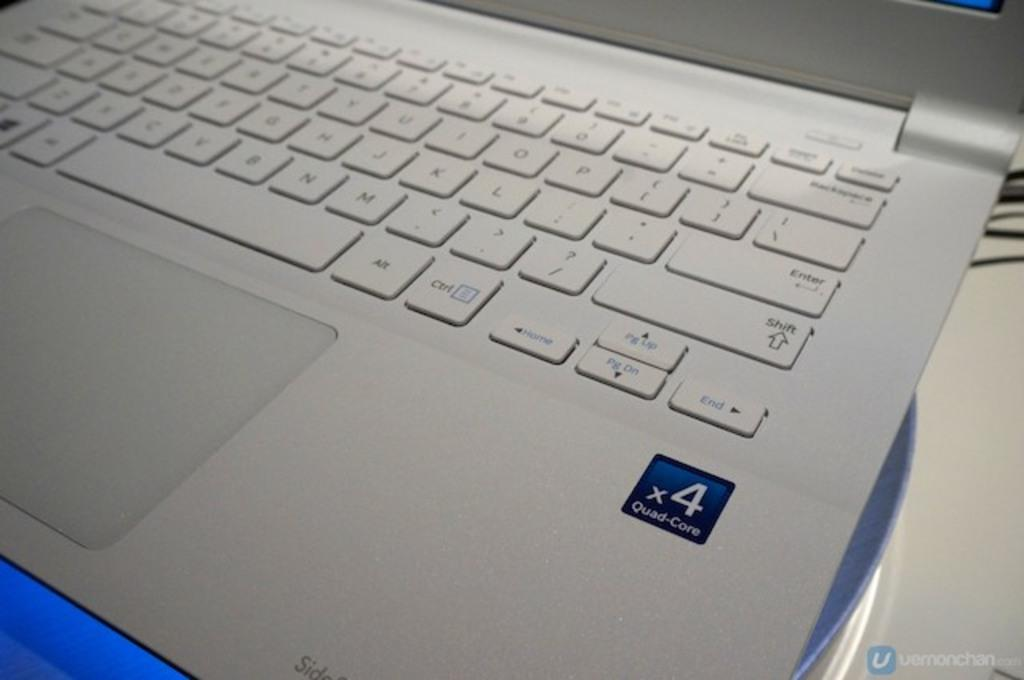<image>
Render a clear and concise summary of the photo. A x4 Quad Care laptop is open on a desk. 